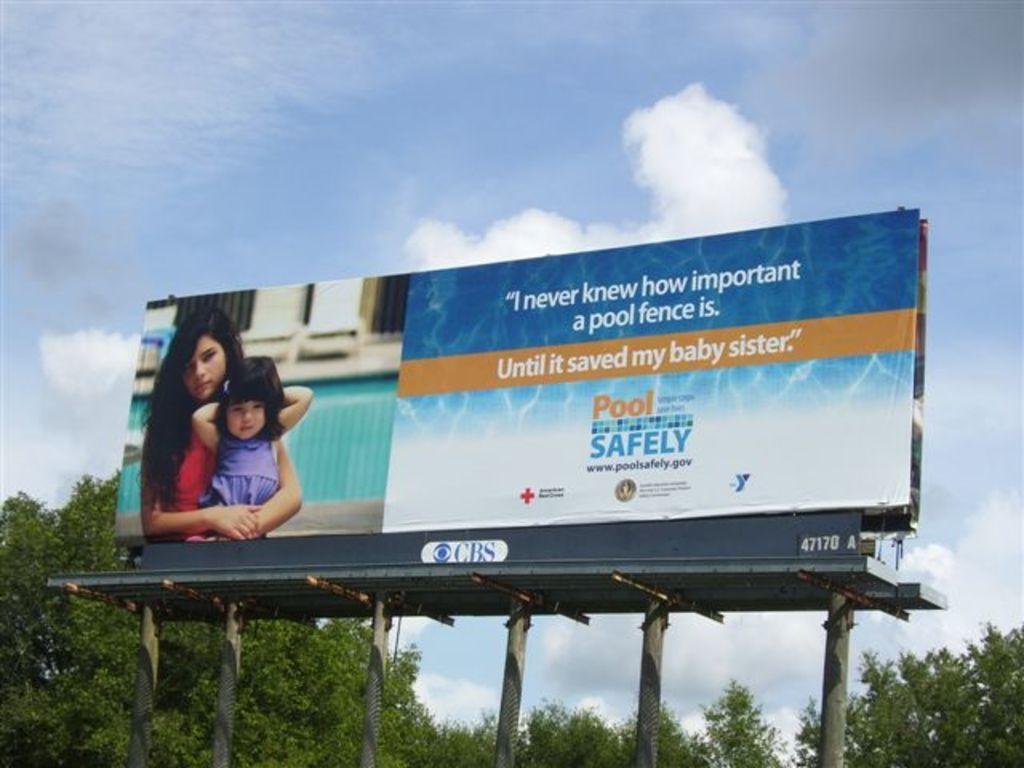Please provide a concise description of this image. In the foreground I can see a hoarding, two persons, text, pillars and metal rods. In the background I can see trees and the sky. This image is taken may be during a day. 